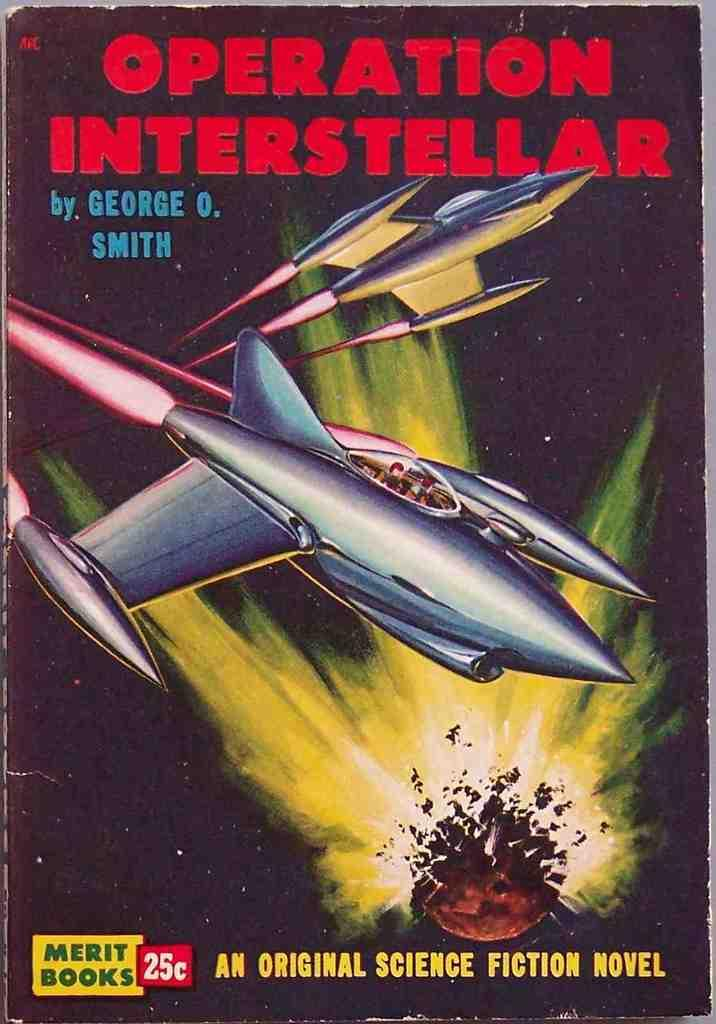What is present in the image related to reading material? There is a book in the image. Can you describe the book's cover? The book has a cover page with text on it. What is depicted on the cover page? The cover page includes the picture of two aircrafts. What type of slave is depicted on the cover page of the book? There is no mention of a slave or any person on the cover page of the book; it features the picture of two aircrafts. 